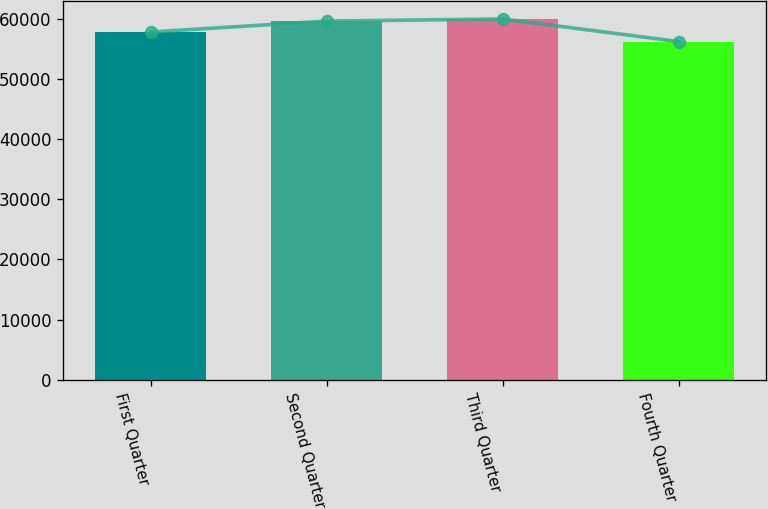<chart> <loc_0><loc_0><loc_500><loc_500><bar_chart><fcel>First Quarter<fcel>Second Quarter<fcel>Third Quarter<fcel>Fourth Quarter<nl><fcel>57767<fcel>59585<fcel>59927<fcel>56181<nl></chart> 